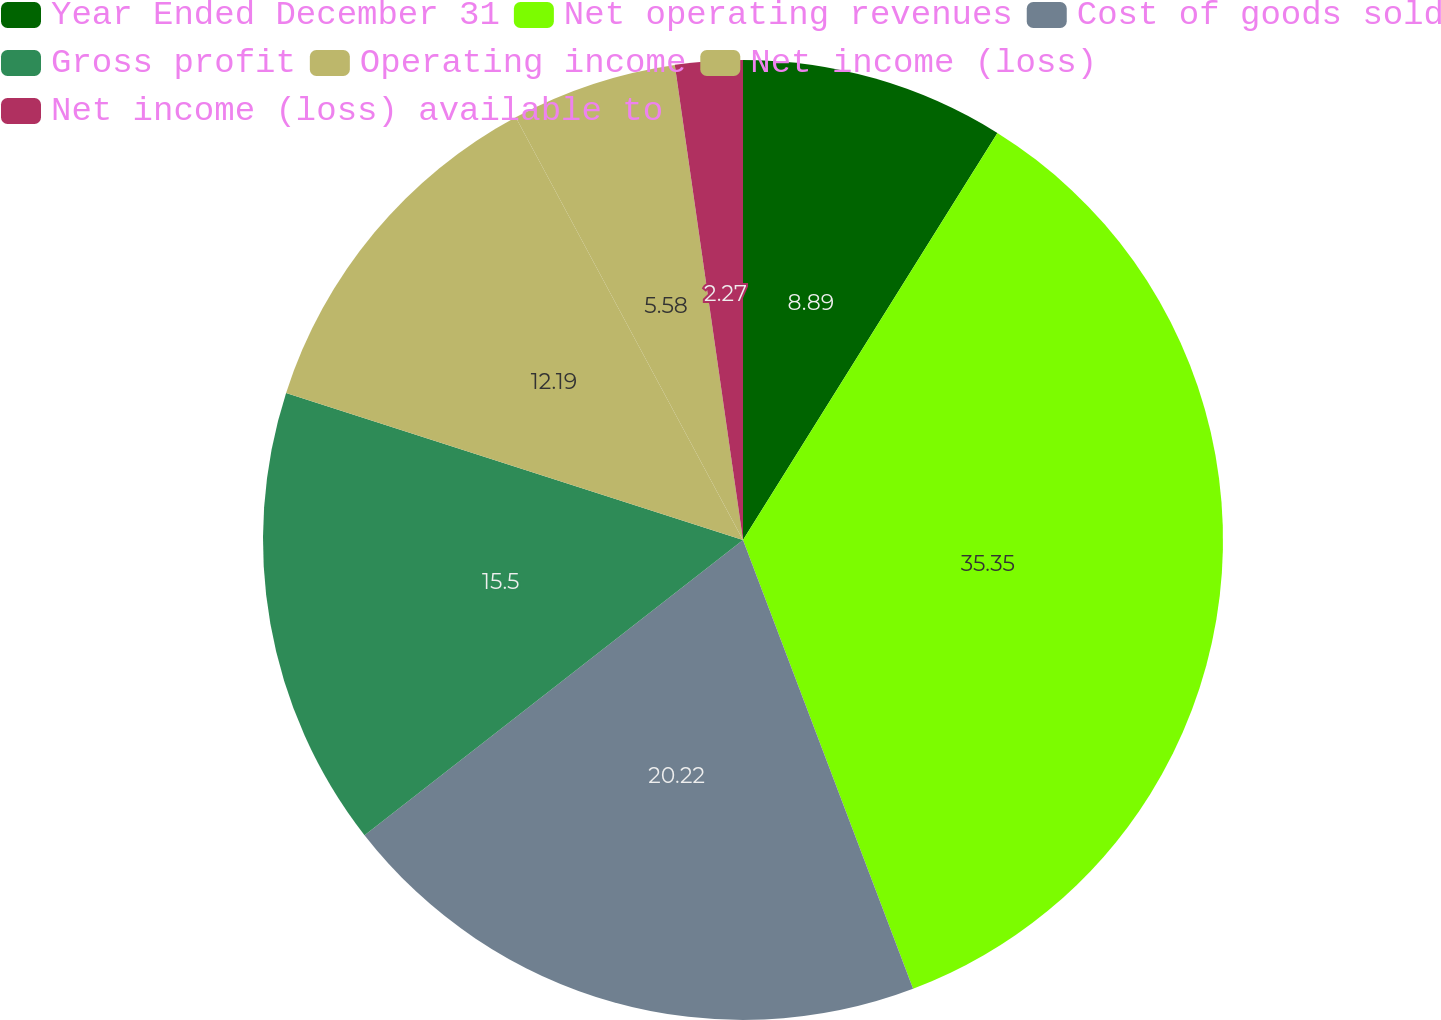Convert chart to OTSL. <chart><loc_0><loc_0><loc_500><loc_500><pie_chart><fcel>Year Ended December 31<fcel>Net operating revenues<fcel>Cost of goods sold<fcel>Gross profit<fcel>Operating income<fcel>Net income (loss)<fcel>Net income (loss) available to<nl><fcel>8.89%<fcel>35.34%<fcel>20.22%<fcel>15.5%<fcel>12.19%<fcel>5.58%<fcel>2.27%<nl></chart> 